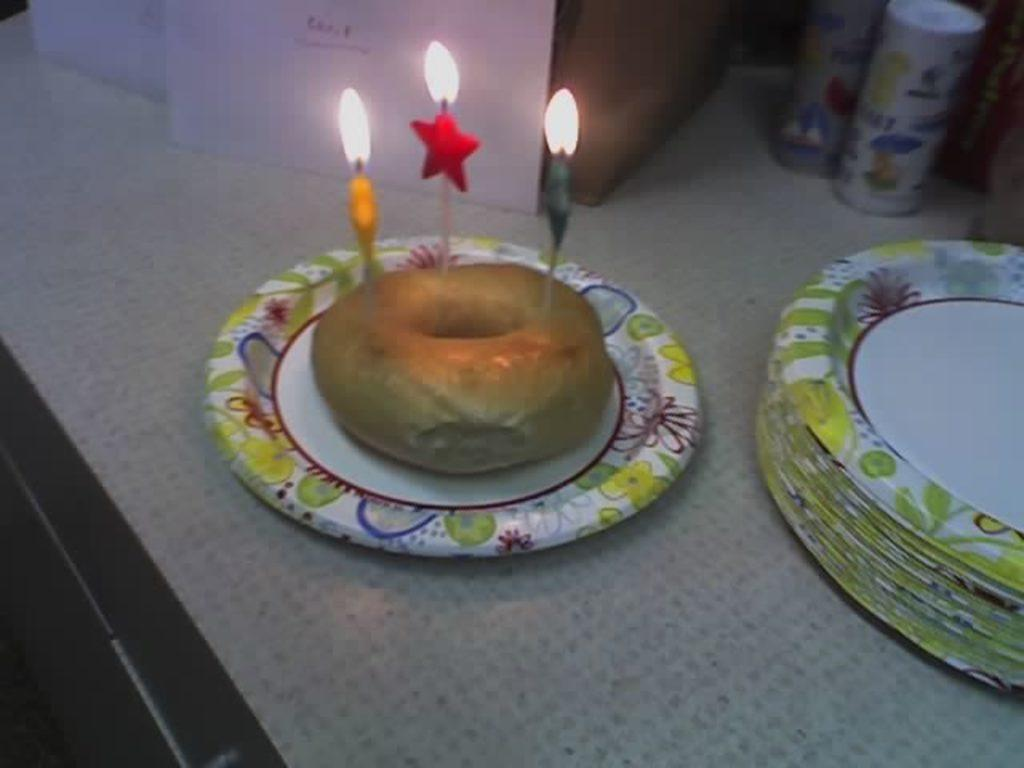What is on the serving plate in the image? The serving plate has a donut on it, and there are candles on the plate as well. What can be seen in the background of the image? Party confetti is visible in the background of the image. Are there any other serving plates in the image? Yes, there are additional serving plates on the table in the background. What type of kettle is visible in the image? There is no kettle present in the image. What view can be seen from the window in the image? There is no window visible in the image. 